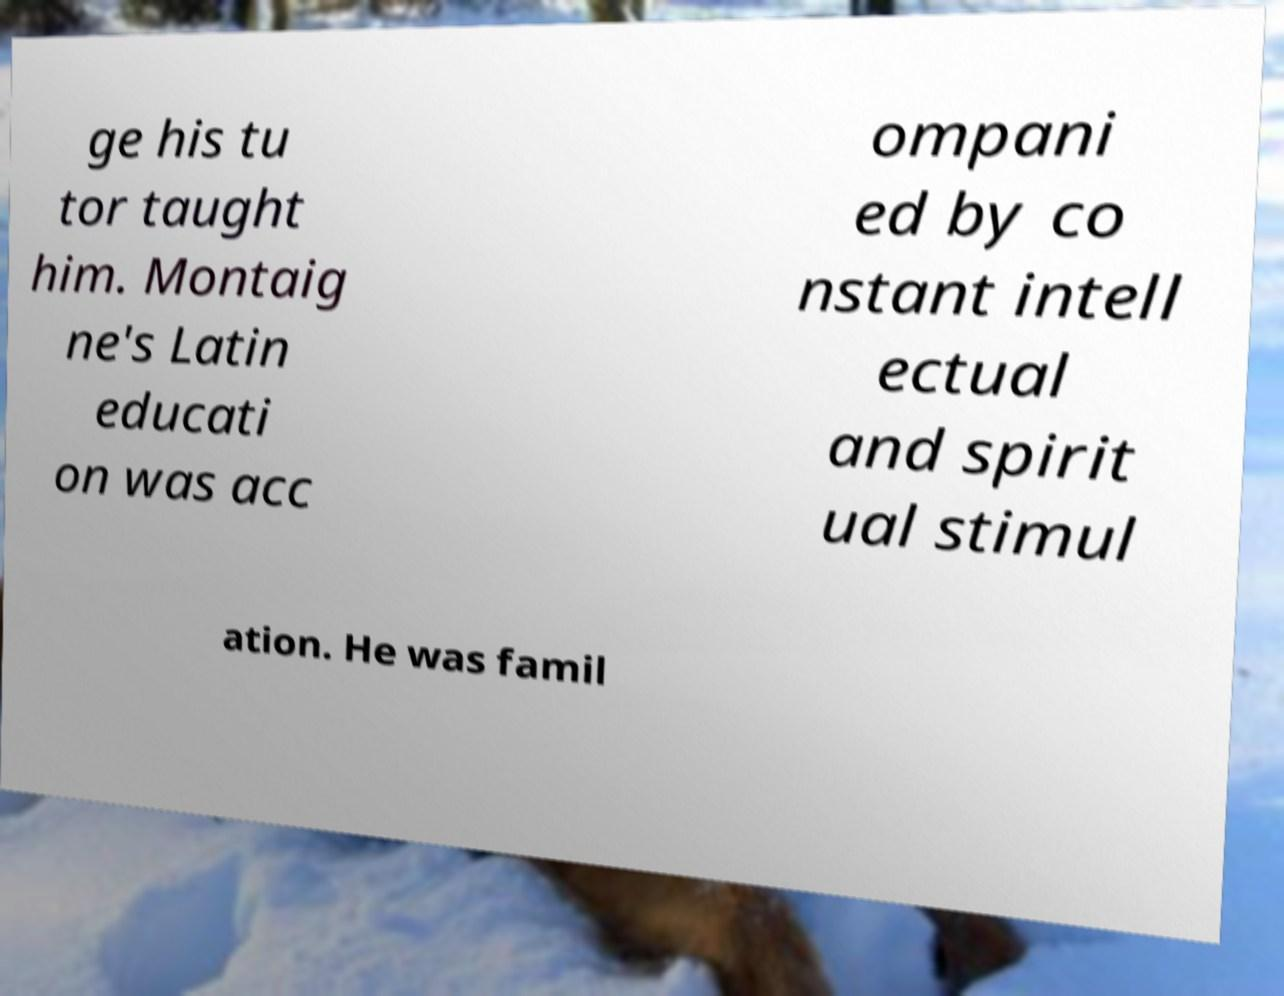Could you extract and type out the text from this image? ge his tu tor taught him. Montaig ne's Latin educati on was acc ompani ed by co nstant intell ectual and spirit ual stimul ation. He was famil 